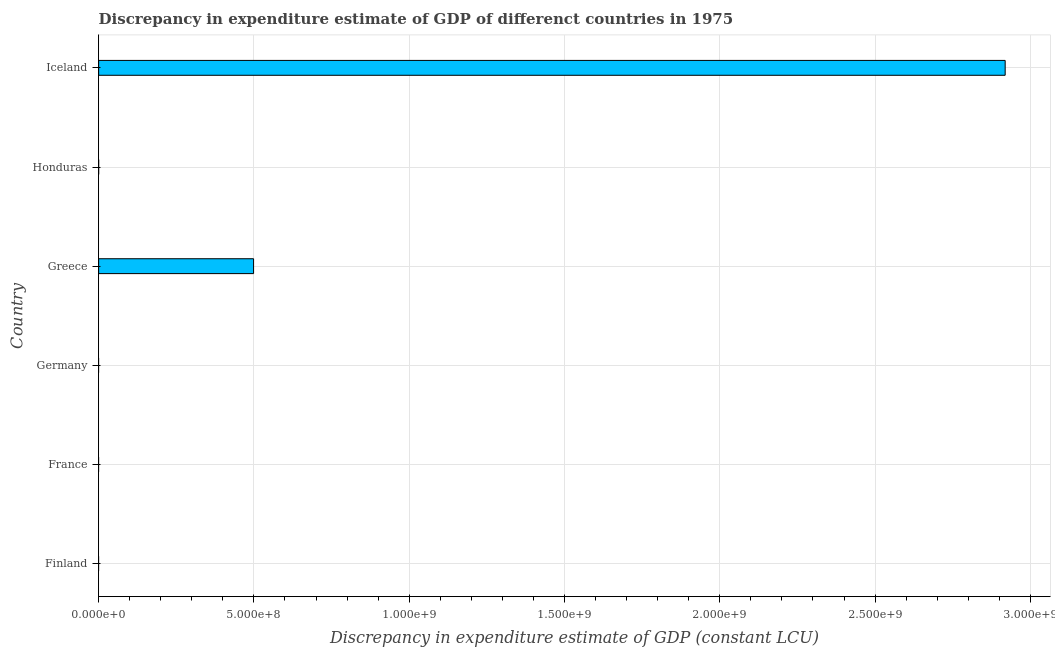Does the graph contain any zero values?
Offer a very short reply. Yes. What is the title of the graph?
Keep it short and to the point. Discrepancy in expenditure estimate of GDP of differenct countries in 1975. What is the label or title of the X-axis?
Offer a very short reply. Discrepancy in expenditure estimate of GDP (constant LCU). What is the label or title of the Y-axis?
Provide a succinct answer. Country. What is the discrepancy in expenditure estimate of gdp in Finland?
Provide a short and direct response. 0. Across all countries, what is the maximum discrepancy in expenditure estimate of gdp?
Offer a very short reply. 2.92e+09. In which country was the discrepancy in expenditure estimate of gdp maximum?
Provide a succinct answer. Iceland. What is the sum of the discrepancy in expenditure estimate of gdp?
Make the answer very short. 3.42e+09. What is the difference between the discrepancy in expenditure estimate of gdp in Greece and Iceland?
Your response must be concise. -2.42e+09. What is the average discrepancy in expenditure estimate of gdp per country?
Ensure brevity in your answer.  5.70e+08. What is the median discrepancy in expenditure estimate of gdp?
Provide a succinct answer. 2.04e+04. In how many countries, is the discrepancy in expenditure estimate of gdp greater than 1000000000 LCU?
Make the answer very short. 1. Is the difference between the discrepancy in expenditure estimate of gdp in Honduras and Iceland greater than the difference between any two countries?
Keep it short and to the point. No. What is the difference between the highest and the second highest discrepancy in expenditure estimate of gdp?
Offer a very short reply. 2.42e+09. What is the difference between the highest and the lowest discrepancy in expenditure estimate of gdp?
Make the answer very short. 2.92e+09. In how many countries, is the discrepancy in expenditure estimate of gdp greater than the average discrepancy in expenditure estimate of gdp taken over all countries?
Provide a short and direct response. 1. How many bars are there?
Offer a very short reply. 3. Are all the bars in the graph horizontal?
Your answer should be compact. Yes. What is the difference between two consecutive major ticks on the X-axis?
Provide a succinct answer. 5.00e+08. Are the values on the major ticks of X-axis written in scientific E-notation?
Provide a succinct answer. Yes. What is the Discrepancy in expenditure estimate of GDP (constant LCU) of Greece?
Keep it short and to the point. 4.99e+08. What is the Discrepancy in expenditure estimate of GDP (constant LCU) of Honduras?
Your answer should be very brief. 4.07e+04. What is the Discrepancy in expenditure estimate of GDP (constant LCU) of Iceland?
Make the answer very short. 2.92e+09. What is the difference between the Discrepancy in expenditure estimate of GDP (constant LCU) in Greece and Honduras?
Your answer should be very brief. 4.99e+08. What is the difference between the Discrepancy in expenditure estimate of GDP (constant LCU) in Greece and Iceland?
Your answer should be compact. -2.42e+09. What is the difference between the Discrepancy in expenditure estimate of GDP (constant LCU) in Honduras and Iceland?
Keep it short and to the point. -2.92e+09. What is the ratio of the Discrepancy in expenditure estimate of GDP (constant LCU) in Greece to that in Honduras?
Give a very brief answer. 1.23e+04. What is the ratio of the Discrepancy in expenditure estimate of GDP (constant LCU) in Greece to that in Iceland?
Your answer should be compact. 0.17. What is the ratio of the Discrepancy in expenditure estimate of GDP (constant LCU) in Honduras to that in Iceland?
Give a very brief answer. 0. 